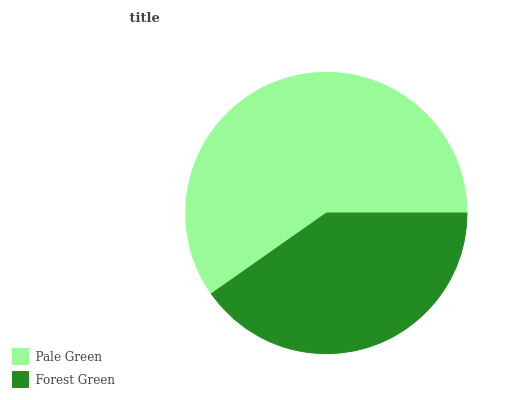Is Forest Green the minimum?
Answer yes or no. Yes. Is Pale Green the maximum?
Answer yes or no. Yes. Is Forest Green the maximum?
Answer yes or no. No. Is Pale Green greater than Forest Green?
Answer yes or no. Yes. Is Forest Green less than Pale Green?
Answer yes or no. Yes. Is Forest Green greater than Pale Green?
Answer yes or no. No. Is Pale Green less than Forest Green?
Answer yes or no. No. Is Pale Green the high median?
Answer yes or no. Yes. Is Forest Green the low median?
Answer yes or no. Yes. Is Forest Green the high median?
Answer yes or no. No. Is Pale Green the low median?
Answer yes or no. No. 